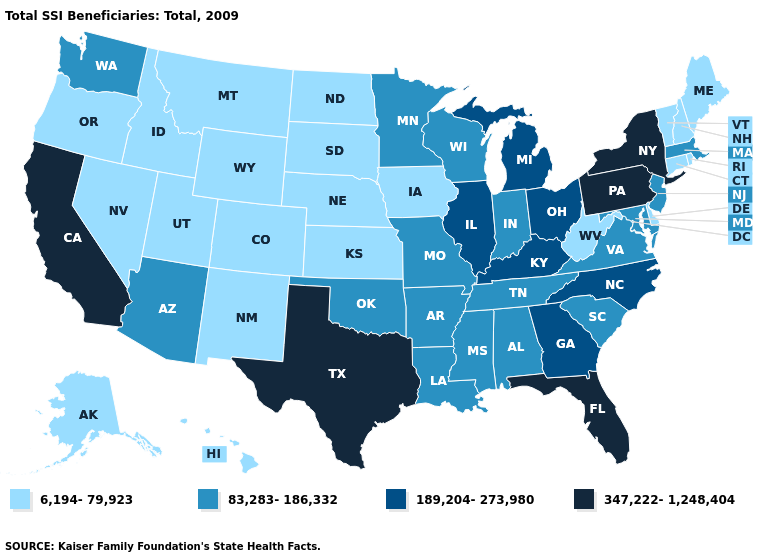Name the states that have a value in the range 347,222-1,248,404?
Answer briefly. California, Florida, New York, Pennsylvania, Texas. What is the value of Arkansas?
Answer briefly. 83,283-186,332. Does West Virginia have the highest value in the South?
Be succinct. No. Name the states that have a value in the range 83,283-186,332?
Quick response, please. Alabama, Arizona, Arkansas, Indiana, Louisiana, Maryland, Massachusetts, Minnesota, Mississippi, Missouri, New Jersey, Oklahoma, South Carolina, Tennessee, Virginia, Washington, Wisconsin. Among the states that border Ohio , which have the highest value?
Give a very brief answer. Pennsylvania. Name the states that have a value in the range 347,222-1,248,404?
Concise answer only. California, Florida, New York, Pennsylvania, Texas. Does Washington have a higher value than New York?
Answer briefly. No. What is the lowest value in the MidWest?
Concise answer only. 6,194-79,923. Name the states that have a value in the range 83,283-186,332?
Short answer required. Alabama, Arizona, Arkansas, Indiana, Louisiana, Maryland, Massachusetts, Minnesota, Mississippi, Missouri, New Jersey, Oklahoma, South Carolina, Tennessee, Virginia, Washington, Wisconsin. Among the states that border Mississippi , which have the lowest value?
Quick response, please. Alabama, Arkansas, Louisiana, Tennessee. Which states have the highest value in the USA?
Be succinct. California, Florida, New York, Pennsylvania, Texas. Does California have the highest value in the West?
Keep it brief. Yes. Name the states that have a value in the range 83,283-186,332?
Give a very brief answer. Alabama, Arizona, Arkansas, Indiana, Louisiana, Maryland, Massachusetts, Minnesota, Mississippi, Missouri, New Jersey, Oklahoma, South Carolina, Tennessee, Virginia, Washington, Wisconsin. What is the highest value in the USA?
Write a very short answer. 347,222-1,248,404. Does the map have missing data?
Quick response, please. No. 